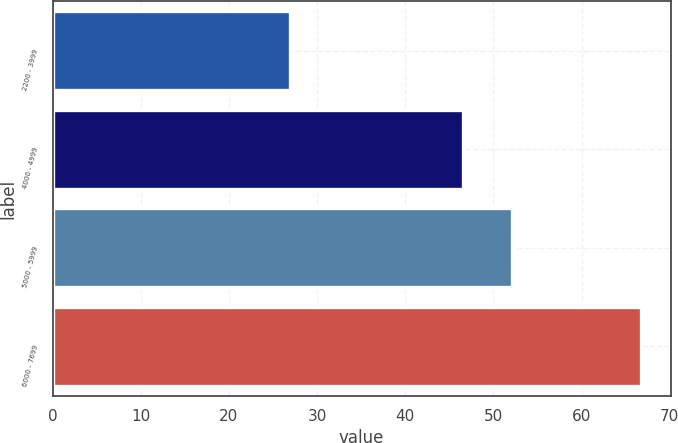<chart> <loc_0><loc_0><loc_500><loc_500><bar_chart><fcel>2200 - 3999<fcel>4000 - 4999<fcel>5000 - 5999<fcel>6000 - 7699<nl><fcel>26.88<fcel>46.51<fcel>52.08<fcel>66.75<nl></chart> 